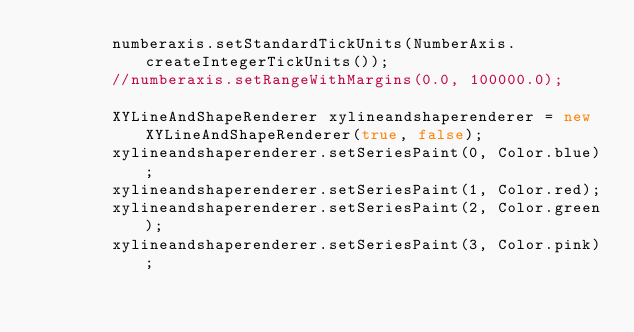<code> <loc_0><loc_0><loc_500><loc_500><_Java_>		numberaxis.setStandardTickUnits(NumberAxis.createIntegerTickUnits());
		//numberaxis.setRangeWithMargins(0.0, 100000.0);
		
		XYLineAndShapeRenderer xylineandshaperenderer = new XYLineAndShapeRenderer(true, false);
		xylineandshaperenderer.setSeriesPaint(0, Color.blue);
		xylineandshaperenderer.setSeriesPaint(1, Color.red);
		xylineandshaperenderer.setSeriesPaint(2, Color.green);
		xylineandshaperenderer.setSeriesPaint(3, Color.pink);</code> 